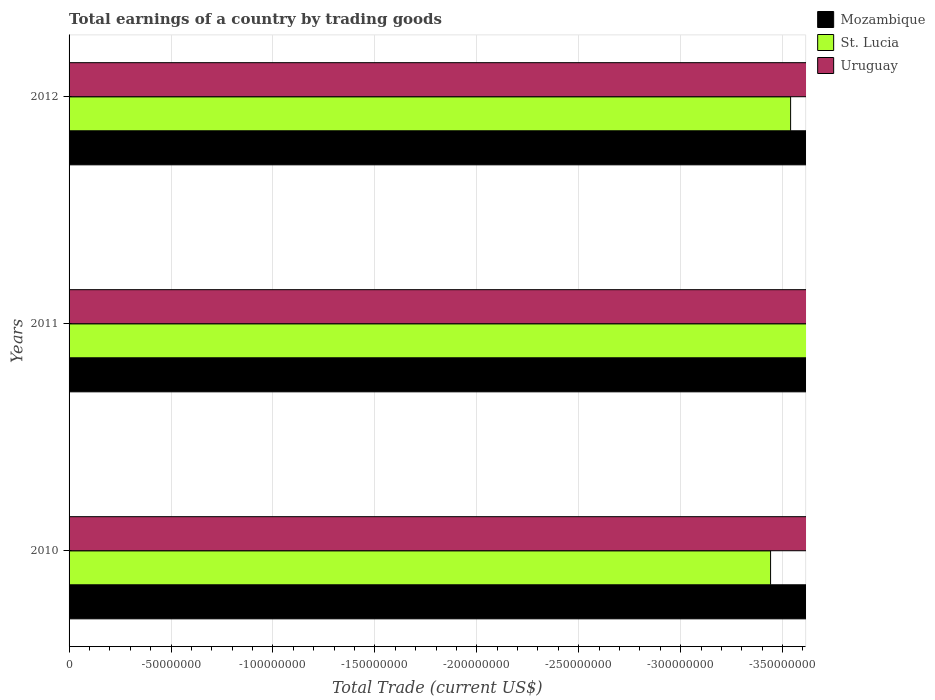Are the number of bars per tick equal to the number of legend labels?
Provide a succinct answer. No. How many bars are there on the 2nd tick from the bottom?
Keep it short and to the point. 0. In how many cases, is the number of bars for a given year not equal to the number of legend labels?
Make the answer very short. 3. Across all years, what is the minimum total earnings in St. Lucia?
Offer a terse response. 0. What is the difference between the total earnings in St. Lucia in 2011 and the total earnings in Uruguay in 2012?
Ensure brevity in your answer.  0. In how many years, is the total earnings in St. Lucia greater than -260000000 US$?
Give a very brief answer. 0. In how many years, is the total earnings in Uruguay greater than the average total earnings in Uruguay taken over all years?
Your answer should be very brief. 0. Are the values on the major ticks of X-axis written in scientific E-notation?
Make the answer very short. No. Does the graph contain any zero values?
Your answer should be compact. Yes. How many legend labels are there?
Give a very brief answer. 3. How are the legend labels stacked?
Provide a short and direct response. Vertical. What is the title of the graph?
Your response must be concise. Total earnings of a country by trading goods. Does "Somalia" appear as one of the legend labels in the graph?
Provide a succinct answer. No. What is the label or title of the X-axis?
Keep it short and to the point. Total Trade (current US$). What is the label or title of the Y-axis?
Offer a terse response. Years. What is the Total Trade (current US$) of Mozambique in 2010?
Give a very brief answer. 0. What is the Total Trade (current US$) in St. Lucia in 2010?
Provide a short and direct response. 0. What is the Total Trade (current US$) in Mozambique in 2011?
Make the answer very short. 0. What is the Total Trade (current US$) in Mozambique in 2012?
Provide a succinct answer. 0. What is the Total Trade (current US$) of St. Lucia in 2012?
Make the answer very short. 0. What is the total Total Trade (current US$) in Mozambique in the graph?
Make the answer very short. 0. What is the total Total Trade (current US$) of St. Lucia in the graph?
Offer a terse response. 0. What is the total Total Trade (current US$) in Uruguay in the graph?
Offer a terse response. 0. What is the average Total Trade (current US$) of Mozambique per year?
Your answer should be compact. 0. 